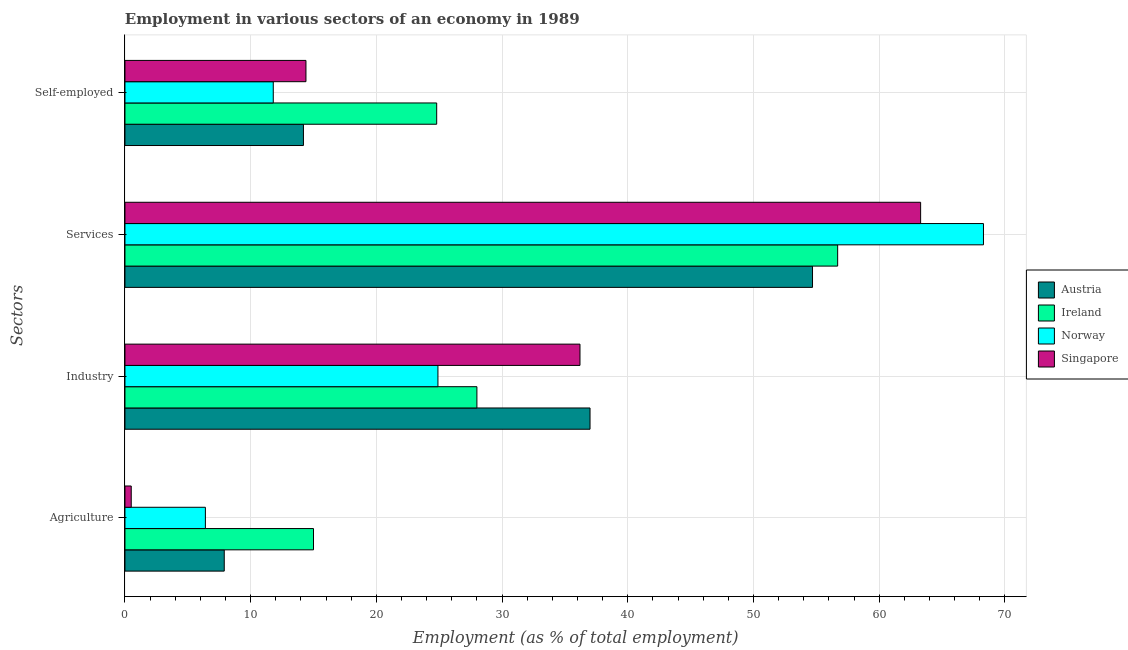How many different coloured bars are there?
Give a very brief answer. 4. How many bars are there on the 1st tick from the top?
Keep it short and to the point. 4. How many bars are there on the 4th tick from the bottom?
Keep it short and to the point. 4. What is the label of the 4th group of bars from the top?
Your answer should be very brief. Agriculture. What is the percentage of workers in industry in Singapore?
Your answer should be very brief. 36.2. Across all countries, what is the maximum percentage of self employed workers?
Offer a very short reply. 24.8. In which country was the percentage of workers in agriculture maximum?
Give a very brief answer. Ireland. What is the total percentage of workers in industry in the graph?
Your answer should be compact. 126.1. What is the difference between the percentage of self employed workers in Austria and that in Norway?
Offer a terse response. 2.4. What is the difference between the percentage of workers in industry in Singapore and the percentage of workers in services in Ireland?
Make the answer very short. -20.5. What is the average percentage of workers in agriculture per country?
Your answer should be very brief. 7.45. What is the difference between the percentage of workers in services and percentage of workers in industry in Austria?
Offer a very short reply. 17.7. In how many countries, is the percentage of self employed workers greater than 62 %?
Keep it short and to the point. 0. What is the ratio of the percentage of workers in agriculture in Austria to that in Ireland?
Provide a short and direct response. 0.53. Is the percentage of workers in industry in Norway less than that in Austria?
Your response must be concise. Yes. What is the difference between the highest and the second highest percentage of self employed workers?
Provide a short and direct response. 10.4. What is the difference between the highest and the lowest percentage of self employed workers?
Give a very brief answer. 13. In how many countries, is the percentage of workers in industry greater than the average percentage of workers in industry taken over all countries?
Provide a short and direct response. 2. What does the 2nd bar from the bottom in Services represents?
Provide a succinct answer. Ireland. Is it the case that in every country, the sum of the percentage of workers in agriculture and percentage of workers in industry is greater than the percentage of workers in services?
Your response must be concise. No. Are the values on the major ticks of X-axis written in scientific E-notation?
Your answer should be compact. No. Does the graph contain grids?
Keep it short and to the point. Yes. What is the title of the graph?
Make the answer very short. Employment in various sectors of an economy in 1989. What is the label or title of the X-axis?
Ensure brevity in your answer.  Employment (as % of total employment). What is the label or title of the Y-axis?
Ensure brevity in your answer.  Sectors. What is the Employment (as % of total employment) in Austria in Agriculture?
Provide a succinct answer. 7.9. What is the Employment (as % of total employment) of Ireland in Agriculture?
Ensure brevity in your answer.  15. What is the Employment (as % of total employment) in Norway in Agriculture?
Provide a short and direct response. 6.4. What is the Employment (as % of total employment) in Ireland in Industry?
Provide a succinct answer. 28. What is the Employment (as % of total employment) in Norway in Industry?
Make the answer very short. 24.9. What is the Employment (as % of total employment) of Singapore in Industry?
Make the answer very short. 36.2. What is the Employment (as % of total employment) in Austria in Services?
Give a very brief answer. 54.7. What is the Employment (as % of total employment) of Ireland in Services?
Ensure brevity in your answer.  56.7. What is the Employment (as % of total employment) of Norway in Services?
Your answer should be compact. 68.3. What is the Employment (as % of total employment) in Singapore in Services?
Keep it short and to the point. 63.3. What is the Employment (as % of total employment) in Austria in Self-employed?
Provide a short and direct response. 14.2. What is the Employment (as % of total employment) of Ireland in Self-employed?
Your answer should be very brief. 24.8. What is the Employment (as % of total employment) in Norway in Self-employed?
Give a very brief answer. 11.8. What is the Employment (as % of total employment) in Singapore in Self-employed?
Keep it short and to the point. 14.4. Across all Sectors, what is the maximum Employment (as % of total employment) of Austria?
Provide a short and direct response. 54.7. Across all Sectors, what is the maximum Employment (as % of total employment) in Ireland?
Keep it short and to the point. 56.7. Across all Sectors, what is the maximum Employment (as % of total employment) in Norway?
Make the answer very short. 68.3. Across all Sectors, what is the maximum Employment (as % of total employment) in Singapore?
Give a very brief answer. 63.3. Across all Sectors, what is the minimum Employment (as % of total employment) in Austria?
Your answer should be compact. 7.9. Across all Sectors, what is the minimum Employment (as % of total employment) in Norway?
Keep it short and to the point. 6.4. Across all Sectors, what is the minimum Employment (as % of total employment) in Singapore?
Offer a very short reply. 0.5. What is the total Employment (as % of total employment) in Austria in the graph?
Offer a terse response. 113.8. What is the total Employment (as % of total employment) of Ireland in the graph?
Ensure brevity in your answer.  124.5. What is the total Employment (as % of total employment) in Norway in the graph?
Your answer should be very brief. 111.4. What is the total Employment (as % of total employment) in Singapore in the graph?
Give a very brief answer. 114.4. What is the difference between the Employment (as % of total employment) of Austria in Agriculture and that in Industry?
Make the answer very short. -29.1. What is the difference between the Employment (as % of total employment) of Ireland in Agriculture and that in Industry?
Your answer should be very brief. -13. What is the difference between the Employment (as % of total employment) of Norway in Agriculture and that in Industry?
Provide a short and direct response. -18.5. What is the difference between the Employment (as % of total employment) of Singapore in Agriculture and that in Industry?
Offer a terse response. -35.7. What is the difference between the Employment (as % of total employment) of Austria in Agriculture and that in Services?
Offer a very short reply. -46.8. What is the difference between the Employment (as % of total employment) in Ireland in Agriculture and that in Services?
Give a very brief answer. -41.7. What is the difference between the Employment (as % of total employment) in Norway in Agriculture and that in Services?
Give a very brief answer. -61.9. What is the difference between the Employment (as % of total employment) of Singapore in Agriculture and that in Services?
Provide a succinct answer. -62.8. What is the difference between the Employment (as % of total employment) in Austria in Agriculture and that in Self-employed?
Provide a succinct answer. -6.3. What is the difference between the Employment (as % of total employment) in Norway in Agriculture and that in Self-employed?
Offer a terse response. -5.4. What is the difference between the Employment (as % of total employment) in Singapore in Agriculture and that in Self-employed?
Provide a short and direct response. -13.9. What is the difference between the Employment (as % of total employment) in Austria in Industry and that in Services?
Offer a terse response. -17.7. What is the difference between the Employment (as % of total employment) in Ireland in Industry and that in Services?
Provide a succinct answer. -28.7. What is the difference between the Employment (as % of total employment) of Norway in Industry and that in Services?
Ensure brevity in your answer.  -43.4. What is the difference between the Employment (as % of total employment) in Singapore in Industry and that in Services?
Provide a short and direct response. -27.1. What is the difference between the Employment (as % of total employment) of Austria in Industry and that in Self-employed?
Keep it short and to the point. 22.8. What is the difference between the Employment (as % of total employment) of Ireland in Industry and that in Self-employed?
Make the answer very short. 3.2. What is the difference between the Employment (as % of total employment) in Singapore in Industry and that in Self-employed?
Offer a terse response. 21.8. What is the difference between the Employment (as % of total employment) of Austria in Services and that in Self-employed?
Your response must be concise. 40.5. What is the difference between the Employment (as % of total employment) in Ireland in Services and that in Self-employed?
Offer a terse response. 31.9. What is the difference between the Employment (as % of total employment) in Norway in Services and that in Self-employed?
Ensure brevity in your answer.  56.5. What is the difference between the Employment (as % of total employment) in Singapore in Services and that in Self-employed?
Offer a very short reply. 48.9. What is the difference between the Employment (as % of total employment) of Austria in Agriculture and the Employment (as % of total employment) of Ireland in Industry?
Provide a short and direct response. -20.1. What is the difference between the Employment (as % of total employment) in Austria in Agriculture and the Employment (as % of total employment) in Norway in Industry?
Your answer should be compact. -17. What is the difference between the Employment (as % of total employment) of Austria in Agriculture and the Employment (as % of total employment) of Singapore in Industry?
Offer a very short reply. -28.3. What is the difference between the Employment (as % of total employment) in Ireland in Agriculture and the Employment (as % of total employment) in Singapore in Industry?
Give a very brief answer. -21.2. What is the difference between the Employment (as % of total employment) in Norway in Agriculture and the Employment (as % of total employment) in Singapore in Industry?
Offer a terse response. -29.8. What is the difference between the Employment (as % of total employment) in Austria in Agriculture and the Employment (as % of total employment) in Ireland in Services?
Offer a very short reply. -48.8. What is the difference between the Employment (as % of total employment) in Austria in Agriculture and the Employment (as % of total employment) in Norway in Services?
Give a very brief answer. -60.4. What is the difference between the Employment (as % of total employment) in Austria in Agriculture and the Employment (as % of total employment) in Singapore in Services?
Keep it short and to the point. -55.4. What is the difference between the Employment (as % of total employment) of Ireland in Agriculture and the Employment (as % of total employment) of Norway in Services?
Provide a succinct answer. -53.3. What is the difference between the Employment (as % of total employment) in Ireland in Agriculture and the Employment (as % of total employment) in Singapore in Services?
Give a very brief answer. -48.3. What is the difference between the Employment (as % of total employment) in Norway in Agriculture and the Employment (as % of total employment) in Singapore in Services?
Offer a very short reply. -56.9. What is the difference between the Employment (as % of total employment) in Austria in Agriculture and the Employment (as % of total employment) in Ireland in Self-employed?
Keep it short and to the point. -16.9. What is the difference between the Employment (as % of total employment) in Ireland in Agriculture and the Employment (as % of total employment) in Norway in Self-employed?
Ensure brevity in your answer.  3.2. What is the difference between the Employment (as % of total employment) of Norway in Agriculture and the Employment (as % of total employment) of Singapore in Self-employed?
Your response must be concise. -8. What is the difference between the Employment (as % of total employment) of Austria in Industry and the Employment (as % of total employment) of Ireland in Services?
Ensure brevity in your answer.  -19.7. What is the difference between the Employment (as % of total employment) in Austria in Industry and the Employment (as % of total employment) in Norway in Services?
Make the answer very short. -31.3. What is the difference between the Employment (as % of total employment) in Austria in Industry and the Employment (as % of total employment) in Singapore in Services?
Your answer should be compact. -26.3. What is the difference between the Employment (as % of total employment) in Ireland in Industry and the Employment (as % of total employment) in Norway in Services?
Keep it short and to the point. -40.3. What is the difference between the Employment (as % of total employment) in Ireland in Industry and the Employment (as % of total employment) in Singapore in Services?
Keep it short and to the point. -35.3. What is the difference between the Employment (as % of total employment) of Norway in Industry and the Employment (as % of total employment) of Singapore in Services?
Offer a very short reply. -38.4. What is the difference between the Employment (as % of total employment) of Austria in Industry and the Employment (as % of total employment) of Norway in Self-employed?
Your response must be concise. 25.2. What is the difference between the Employment (as % of total employment) of Austria in Industry and the Employment (as % of total employment) of Singapore in Self-employed?
Make the answer very short. 22.6. What is the difference between the Employment (as % of total employment) in Ireland in Industry and the Employment (as % of total employment) in Norway in Self-employed?
Give a very brief answer. 16.2. What is the difference between the Employment (as % of total employment) in Austria in Services and the Employment (as % of total employment) in Ireland in Self-employed?
Provide a succinct answer. 29.9. What is the difference between the Employment (as % of total employment) of Austria in Services and the Employment (as % of total employment) of Norway in Self-employed?
Your response must be concise. 42.9. What is the difference between the Employment (as % of total employment) of Austria in Services and the Employment (as % of total employment) of Singapore in Self-employed?
Your answer should be compact. 40.3. What is the difference between the Employment (as % of total employment) of Ireland in Services and the Employment (as % of total employment) of Norway in Self-employed?
Keep it short and to the point. 44.9. What is the difference between the Employment (as % of total employment) of Ireland in Services and the Employment (as % of total employment) of Singapore in Self-employed?
Make the answer very short. 42.3. What is the difference between the Employment (as % of total employment) in Norway in Services and the Employment (as % of total employment) in Singapore in Self-employed?
Your answer should be very brief. 53.9. What is the average Employment (as % of total employment) of Austria per Sectors?
Provide a short and direct response. 28.45. What is the average Employment (as % of total employment) of Ireland per Sectors?
Make the answer very short. 31.12. What is the average Employment (as % of total employment) of Norway per Sectors?
Offer a very short reply. 27.85. What is the average Employment (as % of total employment) in Singapore per Sectors?
Ensure brevity in your answer.  28.6. What is the difference between the Employment (as % of total employment) in Austria and Employment (as % of total employment) in Norway in Agriculture?
Your answer should be very brief. 1.5. What is the difference between the Employment (as % of total employment) in Austria and Employment (as % of total employment) in Singapore in Agriculture?
Offer a very short reply. 7.4. What is the difference between the Employment (as % of total employment) in Ireland and Employment (as % of total employment) in Singapore in Agriculture?
Provide a succinct answer. 14.5. What is the difference between the Employment (as % of total employment) in Austria and Employment (as % of total employment) in Ireland in Services?
Your answer should be compact. -2. What is the difference between the Employment (as % of total employment) in Austria and Employment (as % of total employment) in Singapore in Services?
Give a very brief answer. -8.6. What is the difference between the Employment (as % of total employment) in Austria and Employment (as % of total employment) in Norway in Self-employed?
Offer a very short reply. 2.4. What is the difference between the Employment (as % of total employment) of Austria and Employment (as % of total employment) of Singapore in Self-employed?
Provide a short and direct response. -0.2. What is the difference between the Employment (as % of total employment) in Norway and Employment (as % of total employment) in Singapore in Self-employed?
Your response must be concise. -2.6. What is the ratio of the Employment (as % of total employment) of Austria in Agriculture to that in Industry?
Provide a short and direct response. 0.21. What is the ratio of the Employment (as % of total employment) in Ireland in Agriculture to that in Industry?
Make the answer very short. 0.54. What is the ratio of the Employment (as % of total employment) of Norway in Agriculture to that in Industry?
Your answer should be very brief. 0.26. What is the ratio of the Employment (as % of total employment) of Singapore in Agriculture to that in Industry?
Your answer should be very brief. 0.01. What is the ratio of the Employment (as % of total employment) in Austria in Agriculture to that in Services?
Provide a succinct answer. 0.14. What is the ratio of the Employment (as % of total employment) of Ireland in Agriculture to that in Services?
Your answer should be compact. 0.26. What is the ratio of the Employment (as % of total employment) of Norway in Agriculture to that in Services?
Ensure brevity in your answer.  0.09. What is the ratio of the Employment (as % of total employment) in Singapore in Agriculture to that in Services?
Your answer should be very brief. 0.01. What is the ratio of the Employment (as % of total employment) of Austria in Agriculture to that in Self-employed?
Your response must be concise. 0.56. What is the ratio of the Employment (as % of total employment) of Ireland in Agriculture to that in Self-employed?
Keep it short and to the point. 0.6. What is the ratio of the Employment (as % of total employment) of Norway in Agriculture to that in Self-employed?
Provide a succinct answer. 0.54. What is the ratio of the Employment (as % of total employment) in Singapore in Agriculture to that in Self-employed?
Make the answer very short. 0.03. What is the ratio of the Employment (as % of total employment) in Austria in Industry to that in Services?
Ensure brevity in your answer.  0.68. What is the ratio of the Employment (as % of total employment) in Ireland in Industry to that in Services?
Offer a terse response. 0.49. What is the ratio of the Employment (as % of total employment) in Norway in Industry to that in Services?
Your answer should be very brief. 0.36. What is the ratio of the Employment (as % of total employment) of Singapore in Industry to that in Services?
Provide a succinct answer. 0.57. What is the ratio of the Employment (as % of total employment) in Austria in Industry to that in Self-employed?
Your answer should be compact. 2.61. What is the ratio of the Employment (as % of total employment) in Ireland in Industry to that in Self-employed?
Your answer should be compact. 1.13. What is the ratio of the Employment (as % of total employment) of Norway in Industry to that in Self-employed?
Ensure brevity in your answer.  2.11. What is the ratio of the Employment (as % of total employment) of Singapore in Industry to that in Self-employed?
Your response must be concise. 2.51. What is the ratio of the Employment (as % of total employment) of Austria in Services to that in Self-employed?
Offer a terse response. 3.85. What is the ratio of the Employment (as % of total employment) of Ireland in Services to that in Self-employed?
Keep it short and to the point. 2.29. What is the ratio of the Employment (as % of total employment) of Norway in Services to that in Self-employed?
Your response must be concise. 5.79. What is the ratio of the Employment (as % of total employment) in Singapore in Services to that in Self-employed?
Offer a very short reply. 4.4. What is the difference between the highest and the second highest Employment (as % of total employment) of Austria?
Provide a succinct answer. 17.7. What is the difference between the highest and the second highest Employment (as % of total employment) in Ireland?
Keep it short and to the point. 28.7. What is the difference between the highest and the second highest Employment (as % of total employment) in Norway?
Your response must be concise. 43.4. What is the difference between the highest and the second highest Employment (as % of total employment) in Singapore?
Your response must be concise. 27.1. What is the difference between the highest and the lowest Employment (as % of total employment) of Austria?
Provide a succinct answer. 46.8. What is the difference between the highest and the lowest Employment (as % of total employment) in Ireland?
Give a very brief answer. 41.7. What is the difference between the highest and the lowest Employment (as % of total employment) in Norway?
Provide a succinct answer. 61.9. What is the difference between the highest and the lowest Employment (as % of total employment) in Singapore?
Ensure brevity in your answer.  62.8. 